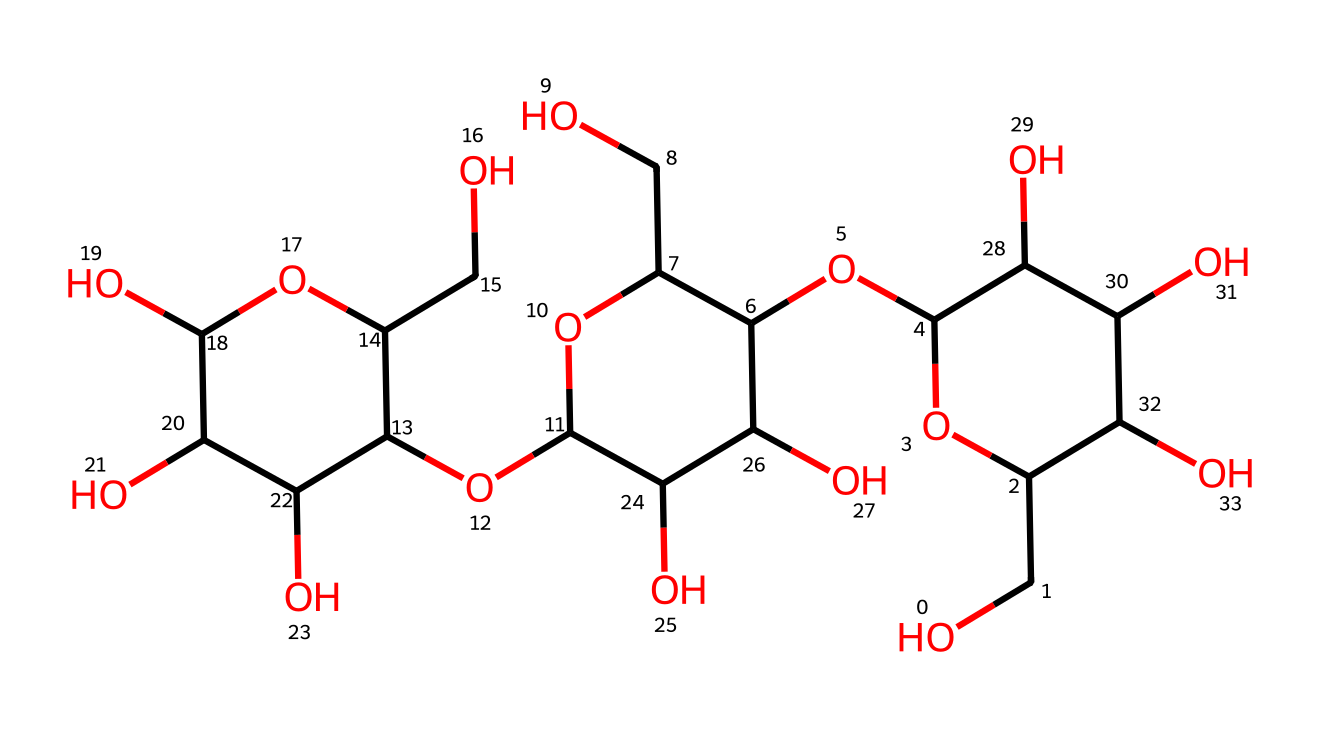What is the primary type of polymer in cotton fibers? Cotton fibers are mainly composed of cellulose, a natural polymer made of glucose units; the structure depicted reflects this polysaccharide nature.
Answer: cellulose How many hydroxyl groups are present in this structure? By examining the structure, each carbon that is part of the sugar units can have a hydroxyl group attached; counting them reveals there are six hydroxyl groups.
Answer: six What role does hydrogen bonding play in cotton fiber properties? The hydroxyl groups in cellulose enable hydrogen bonding, leading to the strength and flexibility of cotton fibers through intermolecular interactions.
Answer: strength How many rings are present in the sugar units of this structure? The structure contains three cyclic forms typical of glucose, as indicated by the cyclic arrangement of the atoms; thus, there are three rings.
Answer: three What is the molecular formula that could represent this chemical structure? Based on the number of carbon, hydrogen, and oxygen atoms counted from the structure, the chemical composition adds up to C6H10O5 repeated in a polymeric unit typical of cellulose.
Answer: C6H10O5 